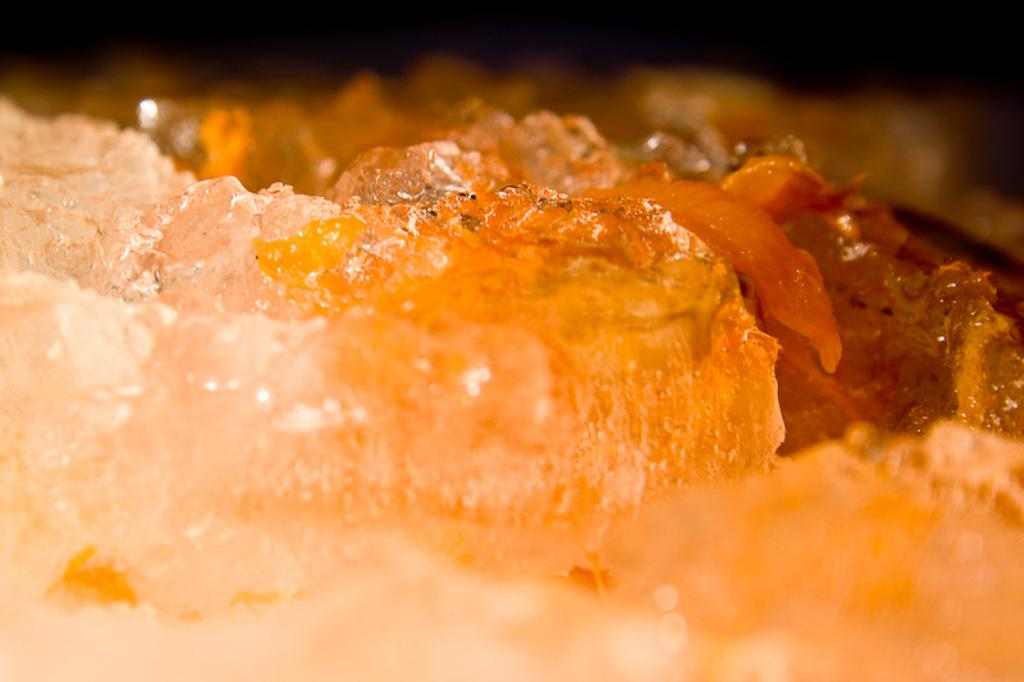What type of object is in the image? There is an edible in the image. Can you describe the colors of the edible? The edible has white and orange colors. How would you describe the background of the image? The background of the image is blurred. What type of apparel is being worn by the soup in the image? There is no soup or apparel present in the image; it features an edible with white and orange colors. 